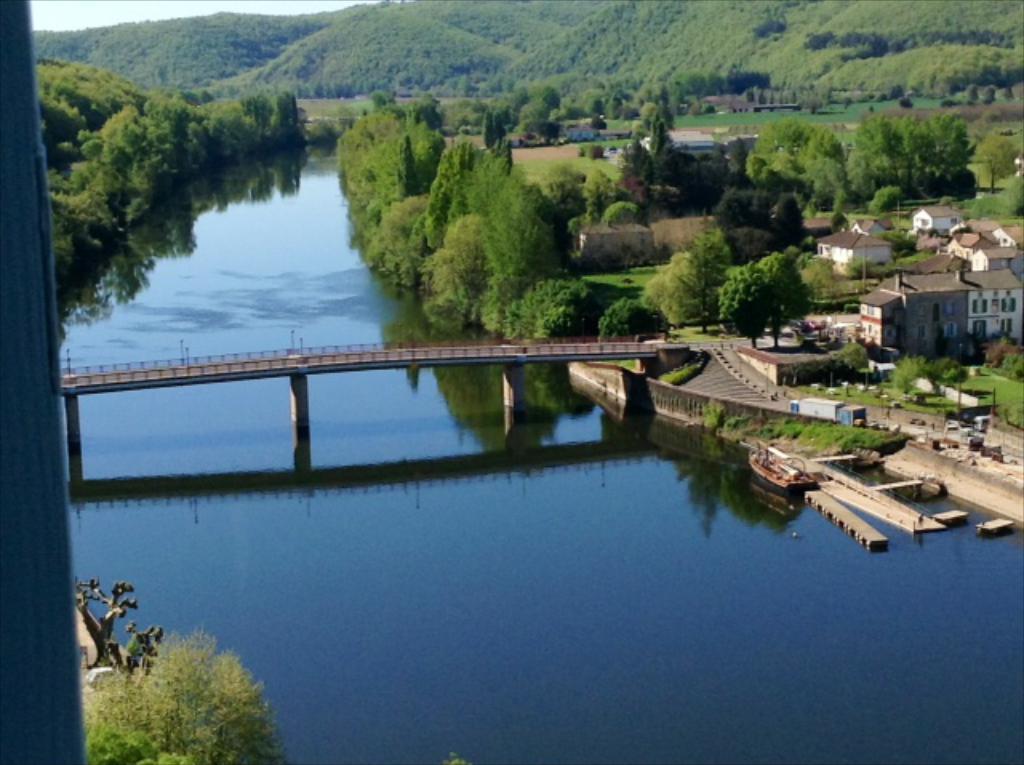In one or two sentences, can you explain what this image depicts? In this image we can see a bridge on the water. Behind the bridge there are groups of trees. On the right side, we can see the houses, grass, plants and the trees. At the top we can see the sky and a group of trees on the hills. 